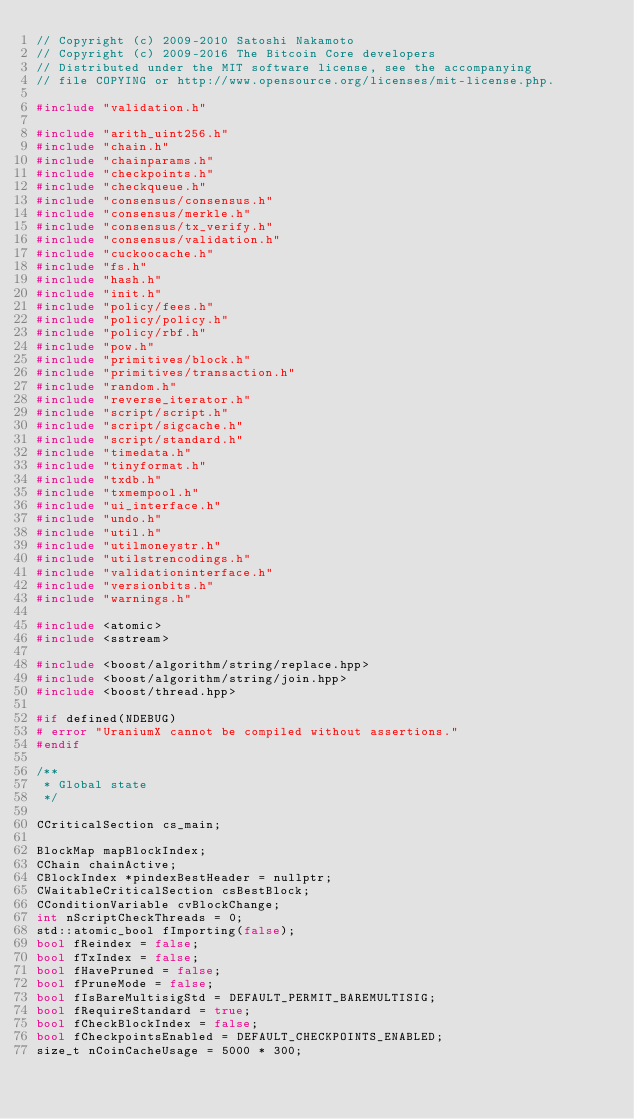Convert code to text. <code><loc_0><loc_0><loc_500><loc_500><_C++_>// Copyright (c) 2009-2010 Satoshi Nakamoto
// Copyright (c) 2009-2016 The Bitcoin Core developers
// Distributed under the MIT software license, see the accompanying
// file COPYING or http://www.opensource.org/licenses/mit-license.php.

#include "validation.h"

#include "arith_uint256.h"
#include "chain.h"
#include "chainparams.h"
#include "checkpoints.h"
#include "checkqueue.h"
#include "consensus/consensus.h"
#include "consensus/merkle.h"
#include "consensus/tx_verify.h"
#include "consensus/validation.h"
#include "cuckoocache.h"
#include "fs.h"
#include "hash.h"
#include "init.h"
#include "policy/fees.h"
#include "policy/policy.h"
#include "policy/rbf.h"
#include "pow.h"
#include "primitives/block.h"
#include "primitives/transaction.h"
#include "random.h"
#include "reverse_iterator.h"
#include "script/script.h"
#include "script/sigcache.h"
#include "script/standard.h"
#include "timedata.h"
#include "tinyformat.h"
#include "txdb.h"
#include "txmempool.h"
#include "ui_interface.h"
#include "undo.h"
#include "util.h"
#include "utilmoneystr.h"
#include "utilstrencodings.h"
#include "validationinterface.h"
#include "versionbits.h"
#include "warnings.h"

#include <atomic>
#include <sstream>

#include <boost/algorithm/string/replace.hpp>
#include <boost/algorithm/string/join.hpp>
#include <boost/thread.hpp>

#if defined(NDEBUG)
# error "UraniumX cannot be compiled without assertions."
#endif

/**
 * Global state
 */

CCriticalSection cs_main;

BlockMap mapBlockIndex;
CChain chainActive;
CBlockIndex *pindexBestHeader = nullptr;
CWaitableCriticalSection csBestBlock;
CConditionVariable cvBlockChange;
int nScriptCheckThreads = 0;
std::atomic_bool fImporting(false);
bool fReindex = false;
bool fTxIndex = false;
bool fHavePruned = false;
bool fPruneMode = false;
bool fIsBareMultisigStd = DEFAULT_PERMIT_BAREMULTISIG;
bool fRequireStandard = true;
bool fCheckBlockIndex = false;
bool fCheckpointsEnabled = DEFAULT_CHECKPOINTS_ENABLED;
size_t nCoinCacheUsage = 5000 * 300;</code> 